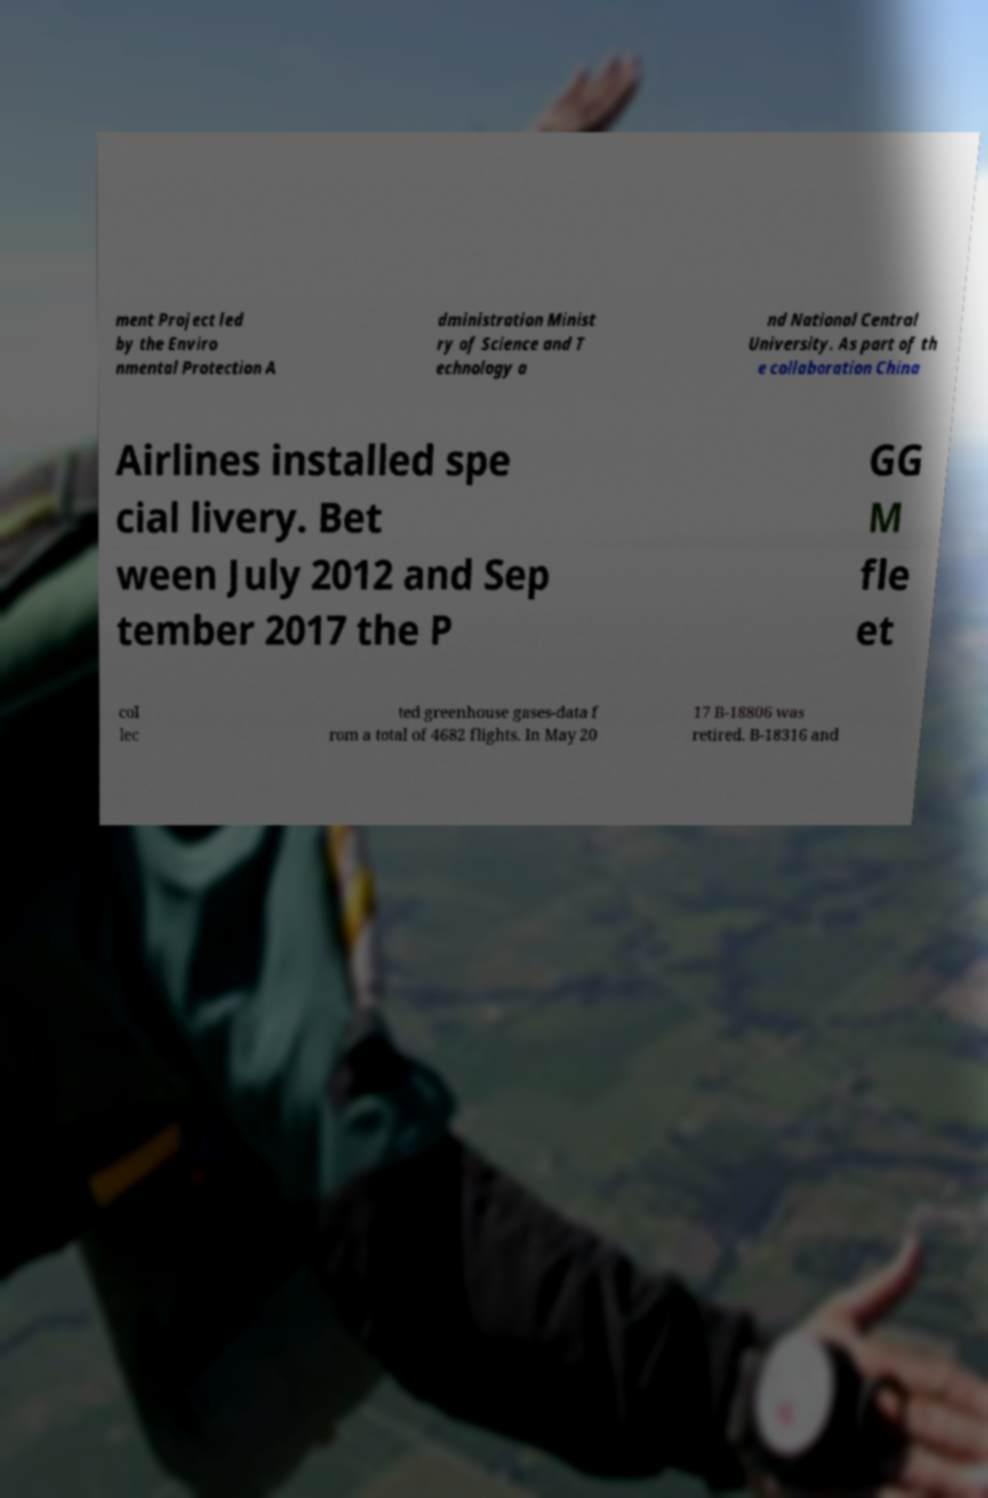Please identify and transcribe the text found in this image. ment Project led by the Enviro nmental Protection A dministration Minist ry of Science and T echnology a nd National Central University. As part of th e collaboration China Airlines installed spe cial livery. Bet ween July 2012 and Sep tember 2017 the P GG M fle et col lec ted greenhouse gases-data f rom a total of 4682 flights. In May 20 17 B-18806 was retired. B-18316 and 